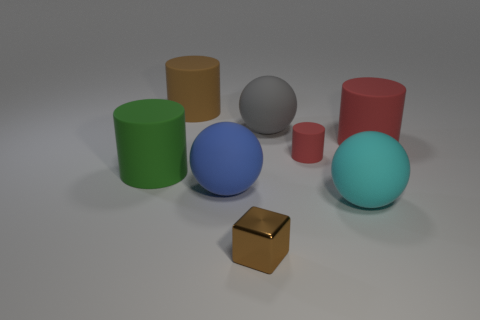The thing to the left of the brown cylinder has what shape?
Make the answer very short. Cylinder. Is the number of large cyan rubber things that are behind the small red rubber cylinder the same as the number of spheres on the right side of the small shiny thing?
Ensure brevity in your answer.  No. How many objects are either brown rubber cylinders or rubber objects left of the shiny thing?
Ensure brevity in your answer.  3. There is a large object that is on the right side of the gray rubber sphere and in front of the small red rubber thing; what is its shape?
Offer a terse response. Sphere. What material is the big gray sphere that is on the left side of the ball in front of the large blue rubber ball made of?
Keep it short and to the point. Rubber. Are the small object on the right side of the small brown block and the large cyan ball made of the same material?
Your answer should be very brief. Yes. There is a matte thing that is to the left of the large brown cylinder; what size is it?
Offer a terse response. Large. There is a big matte cylinder on the right side of the brown rubber cylinder; are there any large green things that are on the right side of it?
Your answer should be very brief. No. Does the matte ball that is behind the blue object have the same color as the big matte sphere that is right of the tiny cylinder?
Your answer should be compact. No. What color is the small matte cylinder?
Provide a succinct answer. Red. 